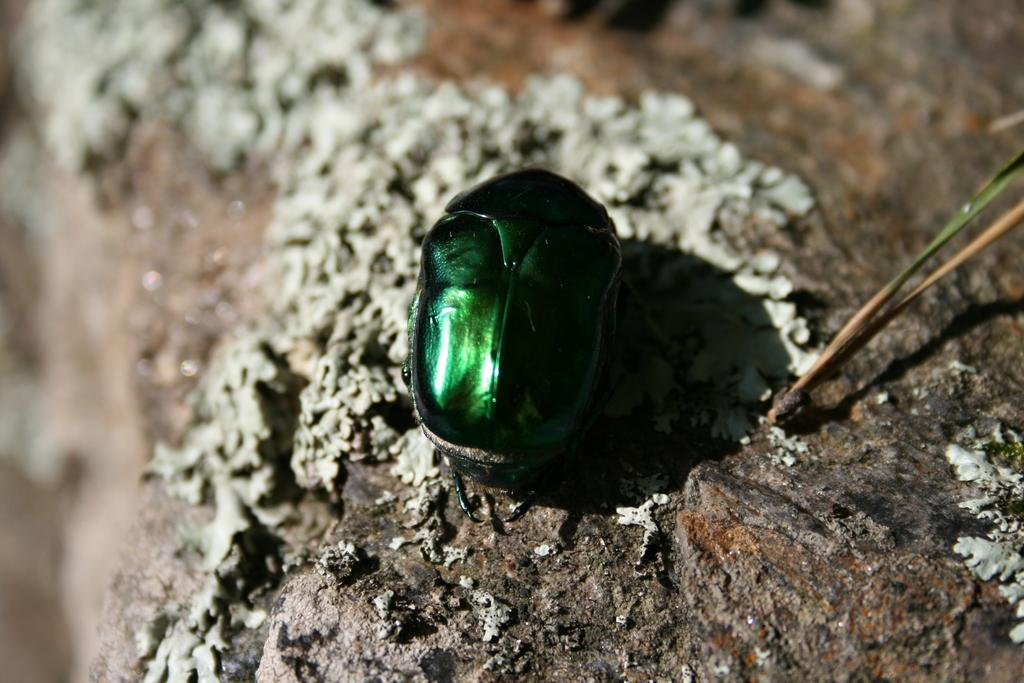What color is the object that can be seen in the image? A: The object in the image has a green color. What type of surface is the green color object placed on? The green color object is on a stone surface. How many birds are in the flock that is visible in the image? There is no flock of birds present in the image; it only features a green color object on a stone surface. 